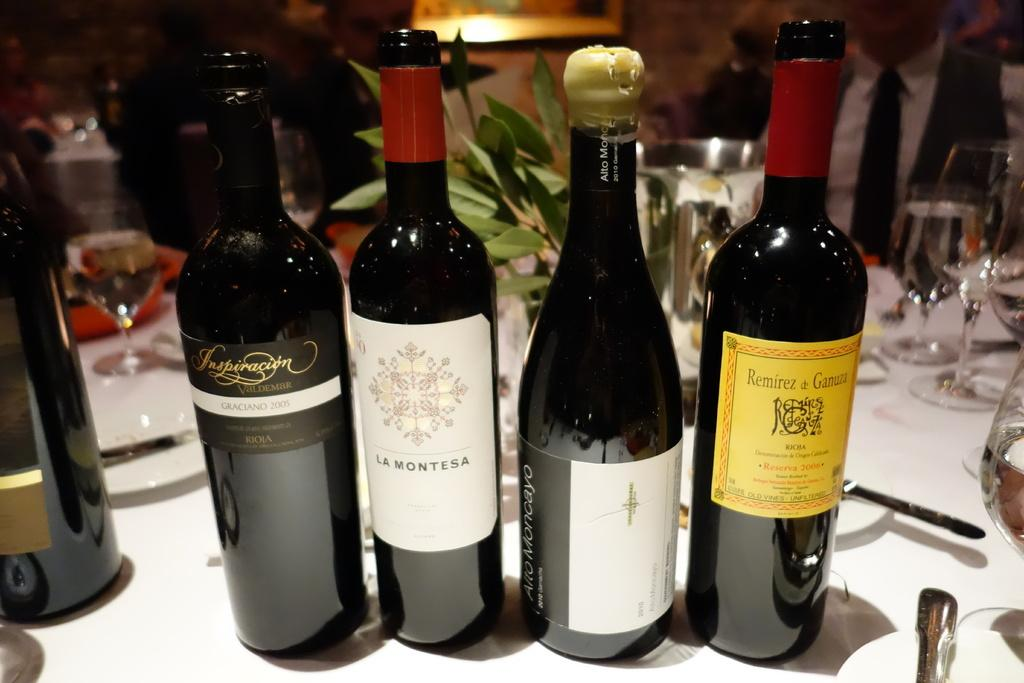Provide a one-sentence caption for the provided image. All of the wine bottles on the table come from regions in France. 